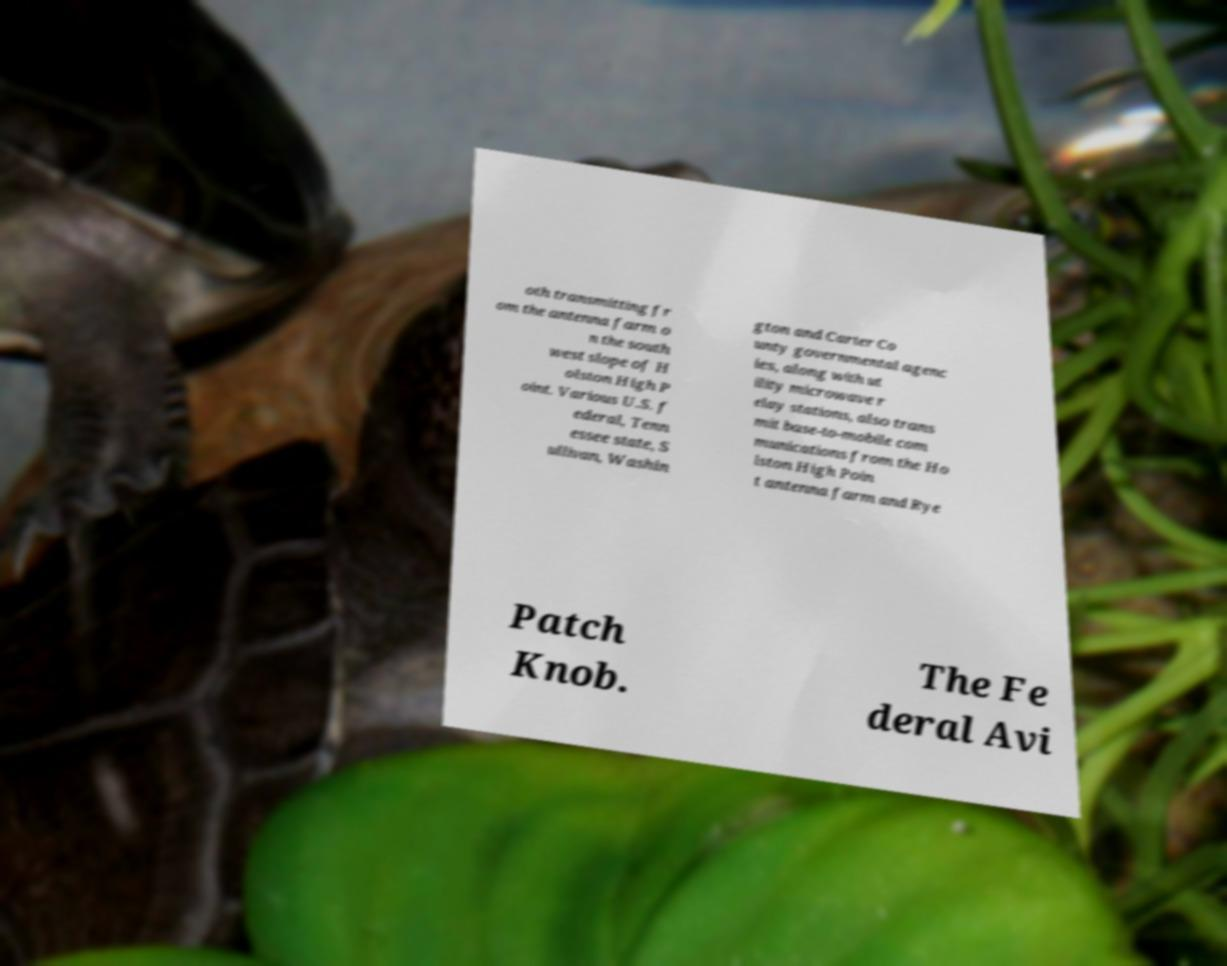I need the written content from this picture converted into text. Can you do that? oth transmitting fr om the antenna farm o n the south west slope of H olston High P oint. Various U.S. f ederal, Tenn essee state, S ullivan, Washin gton and Carter Co unty governmental agenc ies, along with ut ility microwave r elay stations, also trans mit base-to-mobile com munications from the Ho lston High Poin t antenna farm and Rye Patch Knob. The Fe deral Avi 